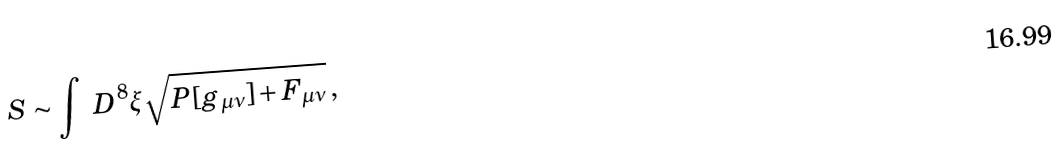Convert formula to latex. <formula><loc_0><loc_0><loc_500><loc_500>S \sim \int \ D ^ { 8 } \xi \sqrt { P [ g _ { \mu \nu } ] + F _ { \mu \nu } } \, ,</formula> 